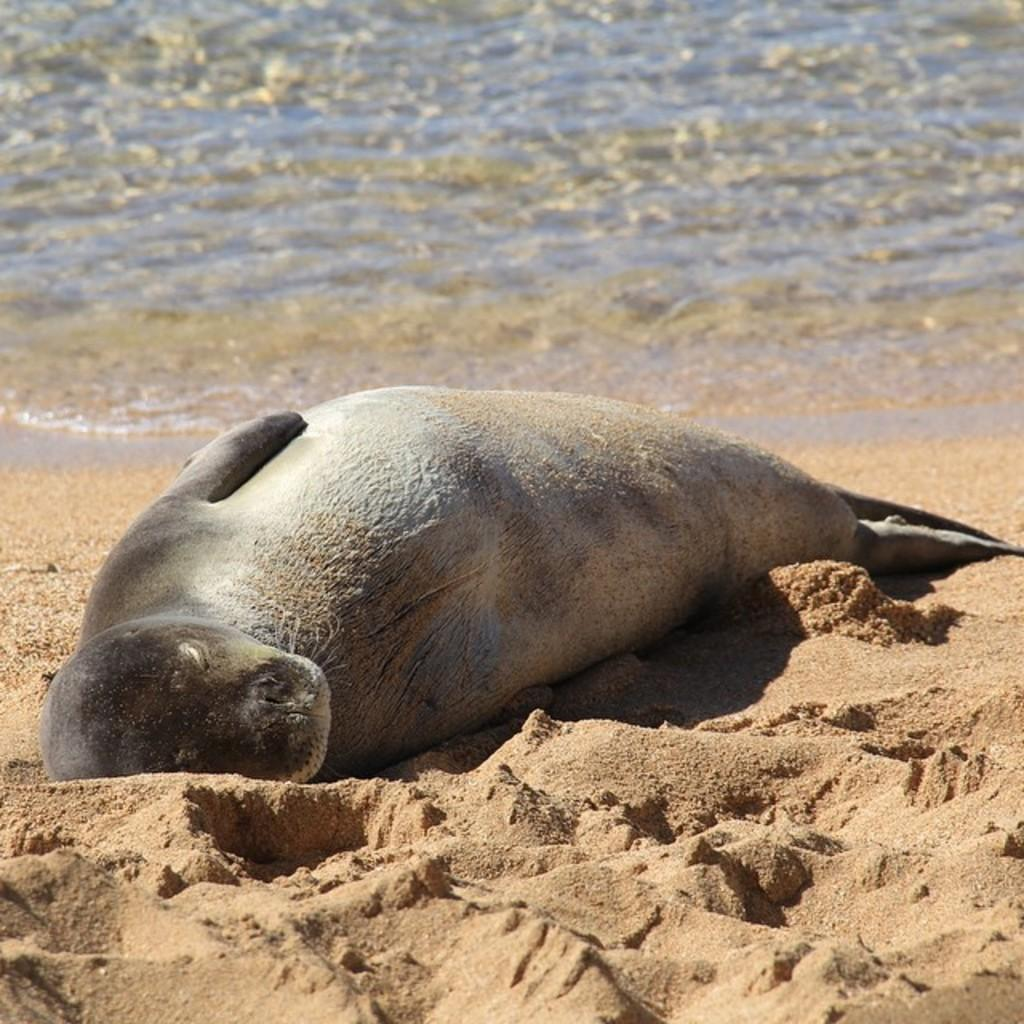What type of animal is in the foreground of the picture? There is a harbor seal animal in the foreground of the picture. What is the harbor seal doing in the picture? The harbor seal is sleeping on the sand. What can be seen in the background of the picture? There is water visible in the background of the picture. What type of watch is the harbor seal wearing in the picture? There is no watch visible on the harbor seal in the picture. 